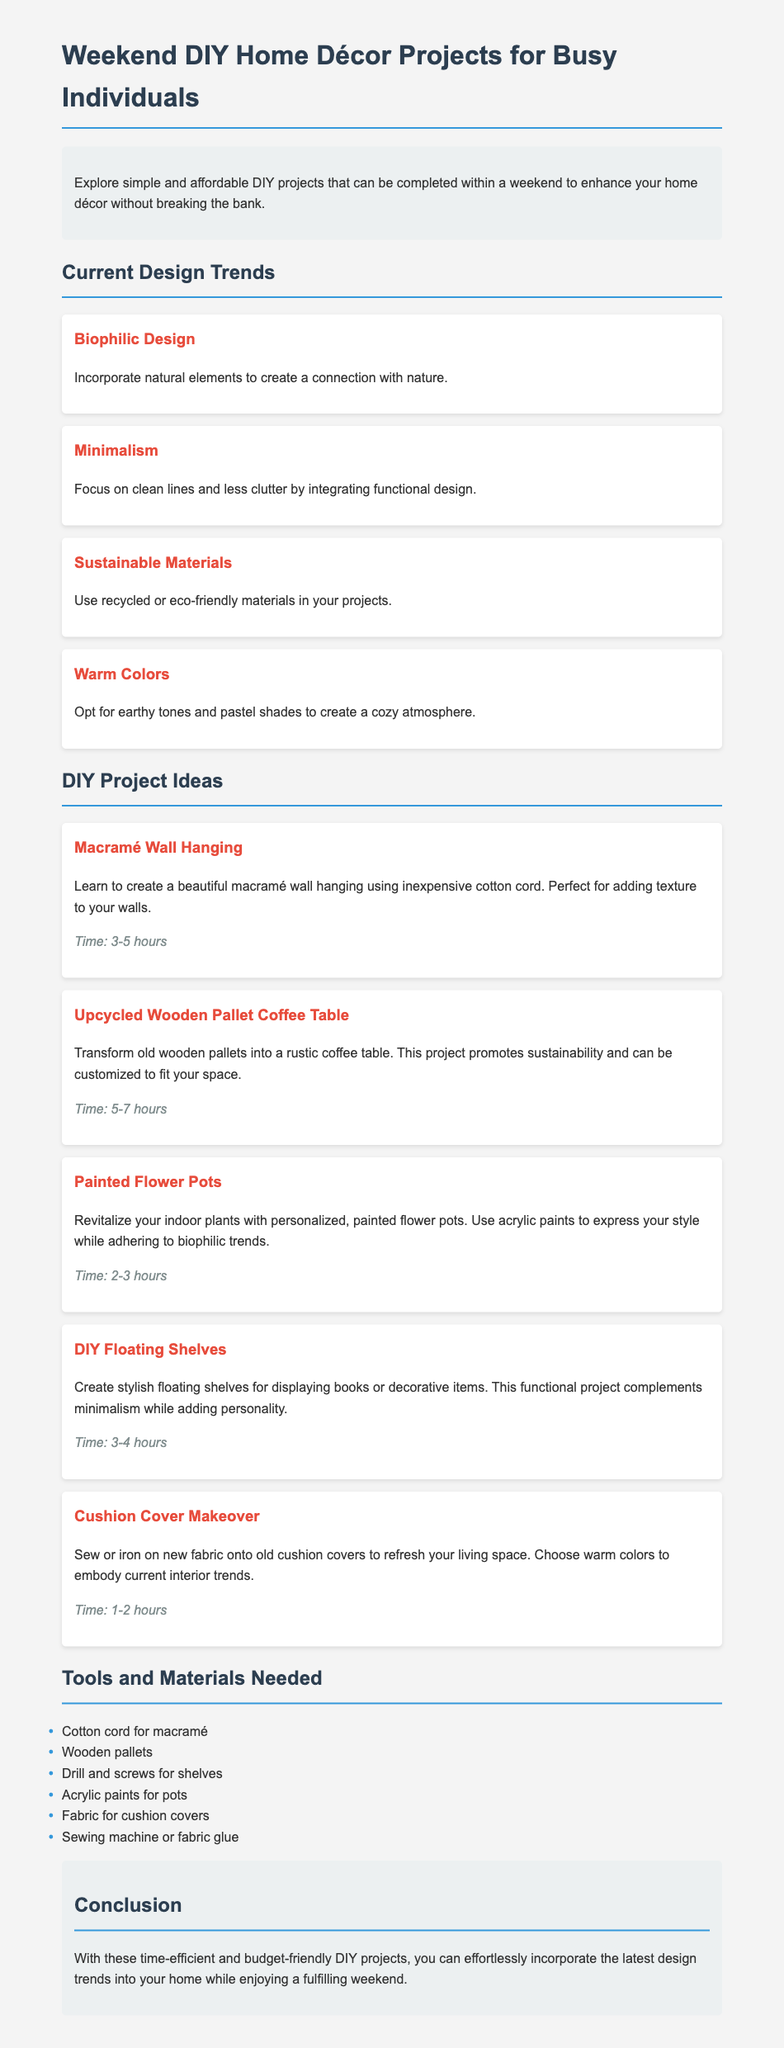What is one current design trend mentioned? The document lists several trends, and one of them is Biophilic Design, which focuses on incorporating natural elements.
Answer: Biophilic Design How long does it take to complete a macramé wall hanging? The time needed to complete the macramé wall hanging project is specified as 3-5 hours.
Answer: 3-5 hours What materials are needed for DIY floating shelves? The document states that a drill and screws are required for creating DIY floating shelves.
Answer: Drill and screws Which DIY project uses recycled materials? The upcycled wooden pallet coffee table project promotes sustainability by using old wooden pallets.
Answer: Upcycled Wooden Pallet Coffee Table What color scheme is suggested for cushion cover makeovers? The document advises using warm colors for the cushion cover makeover to align with current interior trends.
Answer: Warm colors How many DIY project ideas are listed? The document outlines a total of five different DIY project ideas.
Answer: Five What is the focus of the Minimalism trend? The Minimalism trend focuses on integrating functional design while maintaining clean lines and less clutter.
Answer: Clean lines and less clutter What type of paint is recommended for revitalizing flower pots? The document recommends using acrylic paints to personalize and revitalize flower pots.
Answer: Acrylic paints 